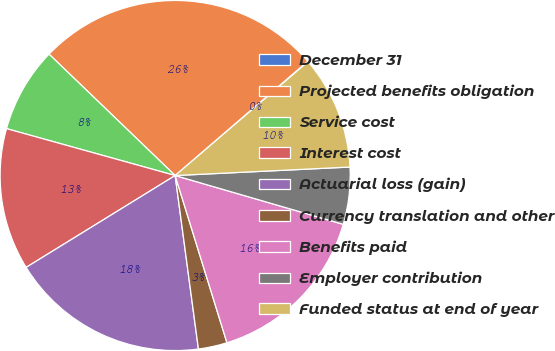<chart> <loc_0><loc_0><loc_500><loc_500><pie_chart><fcel>December 31<fcel>Projected benefits obligation<fcel>Service cost<fcel>Interest cost<fcel>Actuarial loss (gain)<fcel>Currency translation and other<fcel>Benefits paid<fcel>Employer contribution<fcel>Funded status at end of year<nl><fcel>0.05%<fcel>26.48%<fcel>7.88%<fcel>13.11%<fcel>18.33%<fcel>2.66%<fcel>15.72%<fcel>5.27%<fcel>10.5%<nl></chart> 